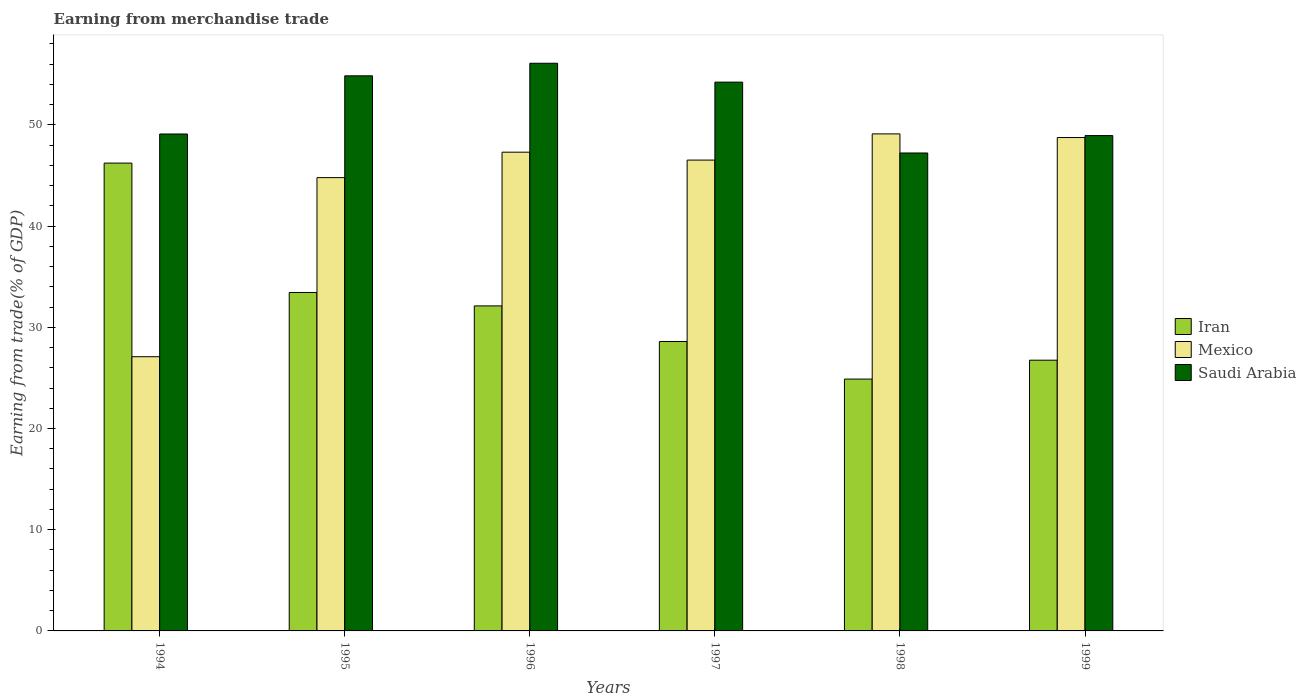How many groups of bars are there?
Your answer should be very brief. 6. Are the number of bars per tick equal to the number of legend labels?
Your answer should be very brief. Yes. What is the label of the 5th group of bars from the left?
Your answer should be compact. 1998. What is the earnings from trade in Mexico in 1999?
Your response must be concise. 48.75. Across all years, what is the maximum earnings from trade in Saudi Arabia?
Your answer should be compact. 56.09. Across all years, what is the minimum earnings from trade in Iran?
Your answer should be very brief. 24.88. What is the total earnings from trade in Iran in the graph?
Your response must be concise. 192. What is the difference between the earnings from trade in Iran in 1994 and that in 1999?
Offer a terse response. 19.48. What is the difference between the earnings from trade in Mexico in 1998 and the earnings from trade in Saudi Arabia in 1994?
Keep it short and to the point. 0.01. What is the average earnings from trade in Mexico per year?
Keep it short and to the point. 43.93. In the year 1994, what is the difference between the earnings from trade in Iran and earnings from trade in Mexico?
Give a very brief answer. 19.13. What is the ratio of the earnings from trade in Mexico in 1995 to that in 1998?
Give a very brief answer. 0.91. Is the earnings from trade in Iran in 1994 less than that in 1999?
Provide a short and direct response. No. What is the difference between the highest and the second highest earnings from trade in Mexico?
Your answer should be compact. 0.36. What is the difference between the highest and the lowest earnings from trade in Iran?
Make the answer very short. 21.34. In how many years, is the earnings from trade in Mexico greater than the average earnings from trade in Mexico taken over all years?
Your answer should be very brief. 5. Is the sum of the earnings from trade in Iran in 1997 and 1998 greater than the maximum earnings from trade in Mexico across all years?
Your response must be concise. Yes. What does the 1st bar from the left in 1997 represents?
Make the answer very short. Iran. What does the 3rd bar from the right in 1998 represents?
Ensure brevity in your answer.  Iran. Are all the bars in the graph horizontal?
Offer a very short reply. No. How many years are there in the graph?
Make the answer very short. 6. What is the difference between two consecutive major ticks on the Y-axis?
Your answer should be very brief. 10. Are the values on the major ticks of Y-axis written in scientific E-notation?
Give a very brief answer. No. How many legend labels are there?
Ensure brevity in your answer.  3. What is the title of the graph?
Your answer should be very brief. Earning from merchandise trade. Does "Slovak Republic" appear as one of the legend labels in the graph?
Your response must be concise. No. What is the label or title of the X-axis?
Make the answer very short. Years. What is the label or title of the Y-axis?
Keep it short and to the point. Earning from trade(% of GDP). What is the Earning from trade(% of GDP) of Iran in 1994?
Give a very brief answer. 46.22. What is the Earning from trade(% of GDP) in Mexico in 1994?
Provide a succinct answer. 27.09. What is the Earning from trade(% of GDP) in Saudi Arabia in 1994?
Give a very brief answer. 49.1. What is the Earning from trade(% of GDP) in Iran in 1995?
Give a very brief answer. 33.44. What is the Earning from trade(% of GDP) in Mexico in 1995?
Your response must be concise. 44.79. What is the Earning from trade(% of GDP) in Saudi Arabia in 1995?
Offer a very short reply. 54.85. What is the Earning from trade(% of GDP) in Iran in 1996?
Provide a succinct answer. 32.11. What is the Earning from trade(% of GDP) in Mexico in 1996?
Give a very brief answer. 47.3. What is the Earning from trade(% of GDP) in Saudi Arabia in 1996?
Keep it short and to the point. 56.09. What is the Earning from trade(% of GDP) of Iran in 1997?
Your response must be concise. 28.6. What is the Earning from trade(% of GDP) of Mexico in 1997?
Offer a terse response. 46.52. What is the Earning from trade(% of GDP) of Saudi Arabia in 1997?
Keep it short and to the point. 54.22. What is the Earning from trade(% of GDP) in Iran in 1998?
Provide a succinct answer. 24.88. What is the Earning from trade(% of GDP) of Mexico in 1998?
Your answer should be compact. 49.11. What is the Earning from trade(% of GDP) of Saudi Arabia in 1998?
Provide a succinct answer. 47.22. What is the Earning from trade(% of GDP) of Iran in 1999?
Give a very brief answer. 26.75. What is the Earning from trade(% of GDP) of Mexico in 1999?
Your answer should be very brief. 48.75. What is the Earning from trade(% of GDP) in Saudi Arabia in 1999?
Provide a succinct answer. 48.94. Across all years, what is the maximum Earning from trade(% of GDP) of Iran?
Offer a terse response. 46.22. Across all years, what is the maximum Earning from trade(% of GDP) in Mexico?
Provide a succinct answer. 49.11. Across all years, what is the maximum Earning from trade(% of GDP) in Saudi Arabia?
Make the answer very short. 56.09. Across all years, what is the minimum Earning from trade(% of GDP) of Iran?
Offer a terse response. 24.88. Across all years, what is the minimum Earning from trade(% of GDP) of Mexico?
Provide a short and direct response. 27.09. Across all years, what is the minimum Earning from trade(% of GDP) in Saudi Arabia?
Provide a short and direct response. 47.22. What is the total Earning from trade(% of GDP) of Iran in the graph?
Provide a succinct answer. 192. What is the total Earning from trade(% of GDP) in Mexico in the graph?
Your response must be concise. 263.56. What is the total Earning from trade(% of GDP) of Saudi Arabia in the graph?
Provide a succinct answer. 310.41. What is the difference between the Earning from trade(% of GDP) of Iran in 1994 and that in 1995?
Provide a succinct answer. 12.78. What is the difference between the Earning from trade(% of GDP) in Mexico in 1994 and that in 1995?
Keep it short and to the point. -17.69. What is the difference between the Earning from trade(% of GDP) in Saudi Arabia in 1994 and that in 1995?
Provide a short and direct response. -5.75. What is the difference between the Earning from trade(% of GDP) in Iran in 1994 and that in 1996?
Provide a succinct answer. 14.11. What is the difference between the Earning from trade(% of GDP) in Mexico in 1994 and that in 1996?
Offer a very short reply. -20.21. What is the difference between the Earning from trade(% of GDP) in Saudi Arabia in 1994 and that in 1996?
Provide a succinct answer. -6.99. What is the difference between the Earning from trade(% of GDP) of Iran in 1994 and that in 1997?
Your answer should be compact. 17.63. What is the difference between the Earning from trade(% of GDP) of Mexico in 1994 and that in 1997?
Your response must be concise. -19.43. What is the difference between the Earning from trade(% of GDP) of Saudi Arabia in 1994 and that in 1997?
Your answer should be very brief. -5.12. What is the difference between the Earning from trade(% of GDP) in Iran in 1994 and that in 1998?
Give a very brief answer. 21.34. What is the difference between the Earning from trade(% of GDP) in Mexico in 1994 and that in 1998?
Make the answer very short. -22.02. What is the difference between the Earning from trade(% of GDP) of Saudi Arabia in 1994 and that in 1998?
Ensure brevity in your answer.  1.88. What is the difference between the Earning from trade(% of GDP) of Iran in 1994 and that in 1999?
Provide a succinct answer. 19.48. What is the difference between the Earning from trade(% of GDP) of Mexico in 1994 and that in 1999?
Keep it short and to the point. -21.65. What is the difference between the Earning from trade(% of GDP) in Saudi Arabia in 1994 and that in 1999?
Ensure brevity in your answer.  0.16. What is the difference between the Earning from trade(% of GDP) of Iran in 1995 and that in 1996?
Ensure brevity in your answer.  1.33. What is the difference between the Earning from trade(% of GDP) of Mexico in 1995 and that in 1996?
Your answer should be very brief. -2.52. What is the difference between the Earning from trade(% of GDP) in Saudi Arabia in 1995 and that in 1996?
Your answer should be compact. -1.24. What is the difference between the Earning from trade(% of GDP) of Iran in 1995 and that in 1997?
Offer a very short reply. 4.84. What is the difference between the Earning from trade(% of GDP) of Mexico in 1995 and that in 1997?
Your response must be concise. -1.73. What is the difference between the Earning from trade(% of GDP) in Saudi Arabia in 1995 and that in 1997?
Offer a very short reply. 0.62. What is the difference between the Earning from trade(% of GDP) of Iran in 1995 and that in 1998?
Provide a short and direct response. 8.56. What is the difference between the Earning from trade(% of GDP) in Mexico in 1995 and that in 1998?
Ensure brevity in your answer.  -4.32. What is the difference between the Earning from trade(% of GDP) in Saudi Arabia in 1995 and that in 1998?
Ensure brevity in your answer.  7.62. What is the difference between the Earning from trade(% of GDP) of Iran in 1995 and that in 1999?
Your answer should be compact. 6.69. What is the difference between the Earning from trade(% of GDP) of Mexico in 1995 and that in 1999?
Provide a succinct answer. -3.96. What is the difference between the Earning from trade(% of GDP) in Saudi Arabia in 1995 and that in 1999?
Provide a short and direct response. 5.91. What is the difference between the Earning from trade(% of GDP) in Iran in 1996 and that in 1997?
Offer a terse response. 3.52. What is the difference between the Earning from trade(% of GDP) of Mexico in 1996 and that in 1997?
Your answer should be compact. 0.78. What is the difference between the Earning from trade(% of GDP) in Saudi Arabia in 1996 and that in 1997?
Ensure brevity in your answer.  1.86. What is the difference between the Earning from trade(% of GDP) of Iran in 1996 and that in 1998?
Give a very brief answer. 7.23. What is the difference between the Earning from trade(% of GDP) of Mexico in 1996 and that in 1998?
Offer a very short reply. -1.81. What is the difference between the Earning from trade(% of GDP) of Saudi Arabia in 1996 and that in 1998?
Make the answer very short. 8.87. What is the difference between the Earning from trade(% of GDP) in Iran in 1996 and that in 1999?
Your response must be concise. 5.36. What is the difference between the Earning from trade(% of GDP) of Mexico in 1996 and that in 1999?
Give a very brief answer. -1.45. What is the difference between the Earning from trade(% of GDP) of Saudi Arabia in 1996 and that in 1999?
Your answer should be very brief. 7.15. What is the difference between the Earning from trade(% of GDP) of Iran in 1997 and that in 1998?
Make the answer very short. 3.71. What is the difference between the Earning from trade(% of GDP) in Mexico in 1997 and that in 1998?
Ensure brevity in your answer.  -2.59. What is the difference between the Earning from trade(% of GDP) in Saudi Arabia in 1997 and that in 1998?
Your response must be concise. 7. What is the difference between the Earning from trade(% of GDP) of Iran in 1997 and that in 1999?
Ensure brevity in your answer.  1.85. What is the difference between the Earning from trade(% of GDP) in Mexico in 1997 and that in 1999?
Give a very brief answer. -2.23. What is the difference between the Earning from trade(% of GDP) of Saudi Arabia in 1997 and that in 1999?
Offer a terse response. 5.28. What is the difference between the Earning from trade(% of GDP) in Iran in 1998 and that in 1999?
Keep it short and to the point. -1.86. What is the difference between the Earning from trade(% of GDP) of Mexico in 1998 and that in 1999?
Provide a short and direct response. 0.36. What is the difference between the Earning from trade(% of GDP) in Saudi Arabia in 1998 and that in 1999?
Ensure brevity in your answer.  -1.72. What is the difference between the Earning from trade(% of GDP) of Iran in 1994 and the Earning from trade(% of GDP) of Mexico in 1995?
Your answer should be compact. 1.44. What is the difference between the Earning from trade(% of GDP) of Iran in 1994 and the Earning from trade(% of GDP) of Saudi Arabia in 1995?
Offer a terse response. -8.62. What is the difference between the Earning from trade(% of GDP) in Mexico in 1994 and the Earning from trade(% of GDP) in Saudi Arabia in 1995?
Provide a succinct answer. -27.75. What is the difference between the Earning from trade(% of GDP) in Iran in 1994 and the Earning from trade(% of GDP) in Mexico in 1996?
Give a very brief answer. -1.08. What is the difference between the Earning from trade(% of GDP) in Iran in 1994 and the Earning from trade(% of GDP) in Saudi Arabia in 1996?
Your response must be concise. -9.86. What is the difference between the Earning from trade(% of GDP) in Mexico in 1994 and the Earning from trade(% of GDP) in Saudi Arabia in 1996?
Your answer should be very brief. -28.99. What is the difference between the Earning from trade(% of GDP) of Iran in 1994 and the Earning from trade(% of GDP) of Mexico in 1997?
Your answer should be very brief. -0.3. What is the difference between the Earning from trade(% of GDP) of Iran in 1994 and the Earning from trade(% of GDP) of Saudi Arabia in 1997?
Ensure brevity in your answer.  -8. What is the difference between the Earning from trade(% of GDP) in Mexico in 1994 and the Earning from trade(% of GDP) in Saudi Arabia in 1997?
Give a very brief answer. -27.13. What is the difference between the Earning from trade(% of GDP) of Iran in 1994 and the Earning from trade(% of GDP) of Mexico in 1998?
Give a very brief answer. -2.88. What is the difference between the Earning from trade(% of GDP) of Iran in 1994 and the Earning from trade(% of GDP) of Saudi Arabia in 1998?
Your answer should be compact. -1. What is the difference between the Earning from trade(% of GDP) in Mexico in 1994 and the Earning from trade(% of GDP) in Saudi Arabia in 1998?
Make the answer very short. -20.13. What is the difference between the Earning from trade(% of GDP) of Iran in 1994 and the Earning from trade(% of GDP) of Mexico in 1999?
Give a very brief answer. -2.52. What is the difference between the Earning from trade(% of GDP) in Iran in 1994 and the Earning from trade(% of GDP) in Saudi Arabia in 1999?
Provide a short and direct response. -2.72. What is the difference between the Earning from trade(% of GDP) in Mexico in 1994 and the Earning from trade(% of GDP) in Saudi Arabia in 1999?
Give a very brief answer. -21.85. What is the difference between the Earning from trade(% of GDP) in Iran in 1995 and the Earning from trade(% of GDP) in Mexico in 1996?
Provide a short and direct response. -13.86. What is the difference between the Earning from trade(% of GDP) of Iran in 1995 and the Earning from trade(% of GDP) of Saudi Arabia in 1996?
Ensure brevity in your answer.  -22.65. What is the difference between the Earning from trade(% of GDP) in Mexico in 1995 and the Earning from trade(% of GDP) in Saudi Arabia in 1996?
Provide a succinct answer. -11.3. What is the difference between the Earning from trade(% of GDP) in Iran in 1995 and the Earning from trade(% of GDP) in Mexico in 1997?
Give a very brief answer. -13.08. What is the difference between the Earning from trade(% of GDP) of Iran in 1995 and the Earning from trade(% of GDP) of Saudi Arabia in 1997?
Make the answer very short. -20.78. What is the difference between the Earning from trade(% of GDP) in Mexico in 1995 and the Earning from trade(% of GDP) in Saudi Arabia in 1997?
Keep it short and to the point. -9.44. What is the difference between the Earning from trade(% of GDP) of Iran in 1995 and the Earning from trade(% of GDP) of Mexico in 1998?
Keep it short and to the point. -15.67. What is the difference between the Earning from trade(% of GDP) in Iran in 1995 and the Earning from trade(% of GDP) in Saudi Arabia in 1998?
Make the answer very short. -13.78. What is the difference between the Earning from trade(% of GDP) of Mexico in 1995 and the Earning from trade(% of GDP) of Saudi Arabia in 1998?
Keep it short and to the point. -2.44. What is the difference between the Earning from trade(% of GDP) of Iran in 1995 and the Earning from trade(% of GDP) of Mexico in 1999?
Your answer should be very brief. -15.31. What is the difference between the Earning from trade(% of GDP) in Iran in 1995 and the Earning from trade(% of GDP) in Saudi Arabia in 1999?
Your answer should be very brief. -15.5. What is the difference between the Earning from trade(% of GDP) of Mexico in 1995 and the Earning from trade(% of GDP) of Saudi Arabia in 1999?
Your answer should be compact. -4.15. What is the difference between the Earning from trade(% of GDP) in Iran in 1996 and the Earning from trade(% of GDP) in Mexico in 1997?
Your answer should be compact. -14.41. What is the difference between the Earning from trade(% of GDP) of Iran in 1996 and the Earning from trade(% of GDP) of Saudi Arabia in 1997?
Make the answer very short. -22.11. What is the difference between the Earning from trade(% of GDP) of Mexico in 1996 and the Earning from trade(% of GDP) of Saudi Arabia in 1997?
Make the answer very short. -6.92. What is the difference between the Earning from trade(% of GDP) in Iran in 1996 and the Earning from trade(% of GDP) in Mexico in 1998?
Offer a very short reply. -17. What is the difference between the Earning from trade(% of GDP) in Iran in 1996 and the Earning from trade(% of GDP) in Saudi Arabia in 1998?
Offer a terse response. -15.11. What is the difference between the Earning from trade(% of GDP) of Mexico in 1996 and the Earning from trade(% of GDP) of Saudi Arabia in 1998?
Your answer should be compact. 0.08. What is the difference between the Earning from trade(% of GDP) of Iran in 1996 and the Earning from trade(% of GDP) of Mexico in 1999?
Your answer should be very brief. -16.64. What is the difference between the Earning from trade(% of GDP) in Iran in 1996 and the Earning from trade(% of GDP) in Saudi Arabia in 1999?
Offer a very short reply. -16.83. What is the difference between the Earning from trade(% of GDP) in Mexico in 1996 and the Earning from trade(% of GDP) in Saudi Arabia in 1999?
Your response must be concise. -1.64. What is the difference between the Earning from trade(% of GDP) in Iran in 1997 and the Earning from trade(% of GDP) in Mexico in 1998?
Offer a very short reply. -20.51. What is the difference between the Earning from trade(% of GDP) in Iran in 1997 and the Earning from trade(% of GDP) in Saudi Arabia in 1998?
Offer a very short reply. -18.62. What is the difference between the Earning from trade(% of GDP) of Mexico in 1997 and the Earning from trade(% of GDP) of Saudi Arabia in 1998?
Keep it short and to the point. -0.7. What is the difference between the Earning from trade(% of GDP) of Iran in 1997 and the Earning from trade(% of GDP) of Mexico in 1999?
Offer a very short reply. -20.15. What is the difference between the Earning from trade(% of GDP) of Iran in 1997 and the Earning from trade(% of GDP) of Saudi Arabia in 1999?
Give a very brief answer. -20.34. What is the difference between the Earning from trade(% of GDP) in Mexico in 1997 and the Earning from trade(% of GDP) in Saudi Arabia in 1999?
Make the answer very short. -2.42. What is the difference between the Earning from trade(% of GDP) in Iran in 1998 and the Earning from trade(% of GDP) in Mexico in 1999?
Keep it short and to the point. -23.86. What is the difference between the Earning from trade(% of GDP) of Iran in 1998 and the Earning from trade(% of GDP) of Saudi Arabia in 1999?
Make the answer very short. -24.06. What is the difference between the Earning from trade(% of GDP) in Mexico in 1998 and the Earning from trade(% of GDP) in Saudi Arabia in 1999?
Offer a very short reply. 0.17. What is the average Earning from trade(% of GDP) of Iran per year?
Provide a short and direct response. 32. What is the average Earning from trade(% of GDP) in Mexico per year?
Your answer should be very brief. 43.93. What is the average Earning from trade(% of GDP) of Saudi Arabia per year?
Make the answer very short. 51.74. In the year 1994, what is the difference between the Earning from trade(% of GDP) in Iran and Earning from trade(% of GDP) in Mexico?
Offer a very short reply. 19.13. In the year 1994, what is the difference between the Earning from trade(% of GDP) in Iran and Earning from trade(% of GDP) in Saudi Arabia?
Keep it short and to the point. -2.87. In the year 1994, what is the difference between the Earning from trade(% of GDP) in Mexico and Earning from trade(% of GDP) in Saudi Arabia?
Provide a succinct answer. -22. In the year 1995, what is the difference between the Earning from trade(% of GDP) of Iran and Earning from trade(% of GDP) of Mexico?
Your answer should be very brief. -11.35. In the year 1995, what is the difference between the Earning from trade(% of GDP) of Iran and Earning from trade(% of GDP) of Saudi Arabia?
Keep it short and to the point. -21.41. In the year 1995, what is the difference between the Earning from trade(% of GDP) in Mexico and Earning from trade(% of GDP) in Saudi Arabia?
Offer a terse response. -10.06. In the year 1996, what is the difference between the Earning from trade(% of GDP) of Iran and Earning from trade(% of GDP) of Mexico?
Ensure brevity in your answer.  -15.19. In the year 1996, what is the difference between the Earning from trade(% of GDP) in Iran and Earning from trade(% of GDP) in Saudi Arabia?
Offer a very short reply. -23.97. In the year 1996, what is the difference between the Earning from trade(% of GDP) in Mexico and Earning from trade(% of GDP) in Saudi Arabia?
Ensure brevity in your answer.  -8.79. In the year 1997, what is the difference between the Earning from trade(% of GDP) in Iran and Earning from trade(% of GDP) in Mexico?
Ensure brevity in your answer.  -17.92. In the year 1997, what is the difference between the Earning from trade(% of GDP) in Iran and Earning from trade(% of GDP) in Saudi Arabia?
Provide a short and direct response. -25.63. In the year 1997, what is the difference between the Earning from trade(% of GDP) in Mexico and Earning from trade(% of GDP) in Saudi Arabia?
Your response must be concise. -7.7. In the year 1998, what is the difference between the Earning from trade(% of GDP) in Iran and Earning from trade(% of GDP) in Mexico?
Ensure brevity in your answer.  -24.23. In the year 1998, what is the difference between the Earning from trade(% of GDP) of Iran and Earning from trade(% of GDP) of Saudi Arabia?
Offer a very short reply. -22.34. In the year 1998, what is the difference between the Earning from trade(% of GDP) in Mexico and Earning from trade(% of GDP) in Saudi Arabia?
Keep it short and to the point. 1.89. In the year 1999, what is the difference between the Earning from trade(% of GDP) of Iran and Earning from trade(% of GDP) of Mexico?
Your response must be concise. -22. In the year 1999, what is the difference between the Earning from trade(% of GDP) in Iran and Earning from trade(% of GDP) in Saudi Arabia?
Give a very brief answer. -22.19. In the year 1999, what is the difference between the Earning from trade(% of GDP) in Mexico and Earning from trade(% of GDP) in Saudi Arabia?
Ensure brevity in your answer.  -0.19. What is the ratio of the Earning from trade(% of GDP) in Iran in 1994 to that in 1995?
Your response must be concise. 1.38. What is the ratio of the Earning from trade(% of GDP) in Mexico in 1994 to that in 1995?
Offer a terse response. 0.6. What is the ratio of the Earning from trade(% of GDP) in Saudi Arabia in 1994 to that in 1995?
Offer a very short reply. 0.9. What is the ratio of the Earning from trade(% of GDP) of Iran in 1994 to that in 1996?
Provide a succinct answer. 1.44. What is the ratio of the Earning from trade(% of GDP) of Mexico in 1994 to that in 1996?
Your answer should be very brief. 0.57. What is the ratio of the Earning from trade(% of GDP) of Saudi Arabia in 1994 to that in 1996?
Make the answer very short. 0.88. What is the ratio of the Earning from trade(% of GDP) in Iran in 1994 to that in 1997?
Make the answer very short. 1.62. What is the ratio of the Earning from trade(% of GDP) of Mexico in 1994 to that in 1997?
Offer a terse response. 0.58. What is the ratio of the Earning from trade(% of GDP) of Saudi Arabia in 1994 to that in 1997?
Provide a succinct answer. 0.91. What is the ratio of the Earning from trade(% of GDP) in Iran in 1994 to that in 1998?
Provide a short and direct response. 1.86. What is the ratio of the Earning from trade(% of GDP) in Mexico in 1994 to that in 1998?
Offer a terse response. 0.55. What is the ratio of the Earning from trade(% of GDP) in Saudi Arabia in 1994 to that in 1998?
Offer a very short reply. 1.04. What is the ratio of the Earning from trade(% of GDP) in Iran in 1994 to that in 1999?
Make the answer very short. 1.73. What is the ratio of the Earning from trade(% of GDP) in Mexico in 1994 to that in 1999?
Provide a succinct answer. 0.56. What is the ratio of the Earning from trade(% of GDP) in Saudi Arabia in 1994 to that in 1999?
Provide a succinct answer. 1. What is the ratio of the Earning from trade(% of GDP) in Iran in 1995 to that in 1996?
Offer a very short reply. 1.04. What is the ratio of the Earning from trade(% of GDP) in Mexico in 1995 to that in 1996?
Provide a succinct answer. 0.95. What is the ratio of the Earning from trade(% of GDP) in Saudi Arabia in 1995 to that in 1996?
Ensure brevity in your answer.  0.98. What is the ratio of the Earning from trade(% of GDP) of Iran in 1995 to that in 1997?
Make the answer very short. 1.17. What is the ratio of the Earning from trade(% of GDP) of Mexico in 1995 to that in 1997?
Make the answer very short. 0.96. What is the ratio of the Earning from trade(% of GDP) of Saudi Arabia in 1995 to that in 1997?
Your response must be concise. 1.01. What is the ratio of the Earning from trade(% of GDP) of Iran in 1995 to that in 1998?
Offer a very short reply. 1.34. What is the ratio of the Earning from trade(% of GDP) in Mexico in 1995 to that in 1998?
Your answer should be very brief. 0.91. What is the ratio of the Earning from trade(% of GDP) in Saudi Arabia in 1995 to that in 1998?
Give a very brief answer. 1.16. What is the ratio of the Earning from trade(% of GDP) of Iran in 1995 to that in 1999?
Your response must be concise. 1.25. What is the ratio of the Earning from trade(% of GDP) of Mexico in 1995 to that in 1999?
Offer a terse response. 0.92. What is the ratio of the Earning from trade(% of GDP) in Saudi Arabia in 1995 to that in 1999?
Your answer should be compact. 1.12. What is the ratio of the Earning from trade(% of GDP) of Iran in 1996 to that in 1997?
Keep it short and to the point. 1.12. What is the ratio of the Earning from trade(% of GDP) of Mexico in 1996 to that in 1997?
Keep it short and to the point. 1.02. What is the ratio of the Earning from trade(% of GDP) of Saudi Arabia in 1996 to that in 1997?
Make the answer very short. 1.03. What is the ratio of the Earning from trade(% of GDP) of Iran in 1996 to that in 1998?
Ensure brevity in your answer.  1.29. What is the ratio of the Earning from trade(% of GDP) in Mexico in 1996 to that in 1998?
Keep it short and to the point. 0.96. What is the ratio of the Earning from trade(% of GDP) of Saudi Arabia in 1996 to that in 1998?
Your answer should be compact. 1.19. What is the ratio of the Earning from trade(% of GDP) of Iran in 1996 to that in 1999?
Provide a succinct answer. 1.2. What is the ratio of the Earning from trade(% of GDP) of Mexico in 1996 to that in 1999?
Make the answer very short. 0.97. What is the ratio of the Earning from trade(% of GDP) of Saudi Arabia in 1996 to that in 1999?
Provide a short and direct response. 1.15. What is the ratio of the Earning from trade(% of GDP) in Iran in 1997 to that in 1998?
Offer a very short reply. 1.15. What is the ratio of the Earning from trade(% of GDP) of Mexico in 1997 to that in 1998?
Your response must be concise. 0.95. What is the ratio of the Earning from trade(% of GDP) in Saudi Arabia in 1997 to that in 1998?
Keep it short and to the point. 1.15. What is the ratio of the Earning from trade(% of GDP) in Iran in 1997 to that in 1999?
Provide a short and direct response. 1.07. What is the ratio of the Earning from trade(% of GDP) in Mexico in 1997 to that in 1999?
Offer a terse response. 0.95. What is the ratio of the Earning from trade(% of GDP) of Saudi Arabia in 1997 to that in 1999?
Make the answer very short. 1.11. What is the ratio of the Earning from trade(% of GDP) of Iran in 1998 to that in 1999?
Offer a terse response. 0.93. What is the ratio of the Earning from trade(% of GDP) of Mexico in 1998 to that in 1999?
Keep it short and to the point. 1.01. What is the ratio of the Earning from trade(% of GDP) in Saudi Arabia in 1998 to that in 1999?
Ensure brevity in your answer.  0.96. What is the difference between the highest and the second highest Earning from trade(% of GDP) in Iran?
Give a very brief answer. 12.78. What is the difference between the highest and the second highest Earning from trade(% of GDP) of Mexico?
Give a very brief answer. 0.36. What is the difference between the highest and the second highest Earning from trade(% of GDP) in Saudi Arabia?
Your response must be concise. 1.24. What is the difference between the highest and the lowest Earning from trade(% of GDP) of Iran?
Your response must be concise. 21.34. What is the difference between the highest and the lowest Earning from trade(% of GDP) in Mexico?
Give a very brief answer. 22.02. What is the difference between the highest and the lowest Earning from trade(% of GDP) of Saudi Arabia?
Offer a terse response. 8.87. 